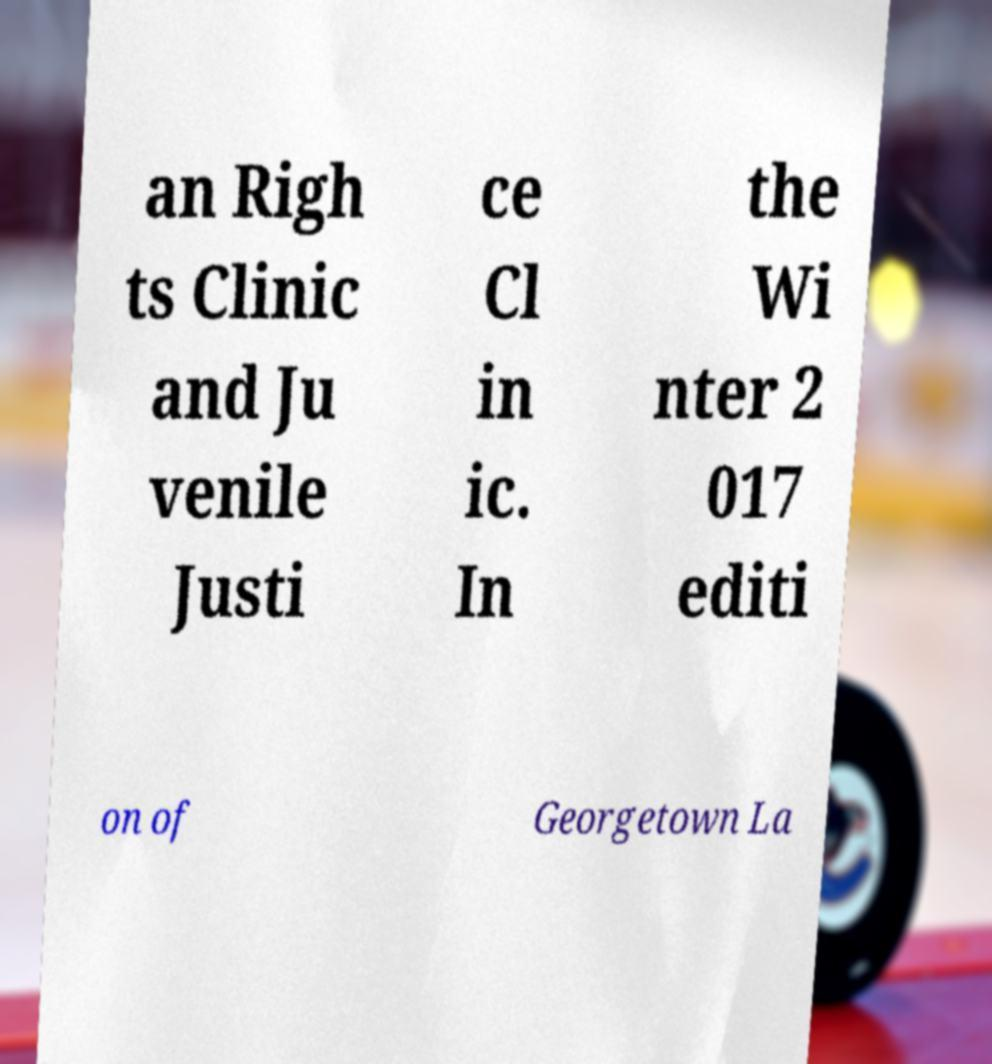For documentation purposes, I need the text within this image transcribed. Could you provide that? an Righ ts Clinic and Ju venile Justi ce Cl in ic. In the Wi nter 2 017 editi on of Georgetown La 